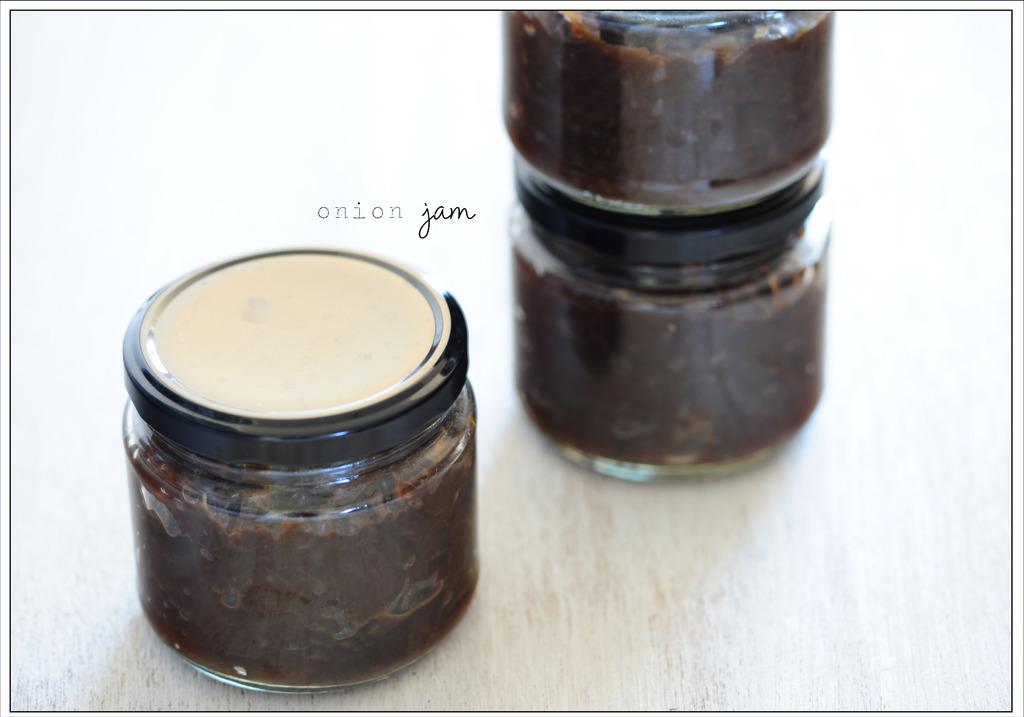What kind of jam is in the jars?
Make the answer very short. Onion. 